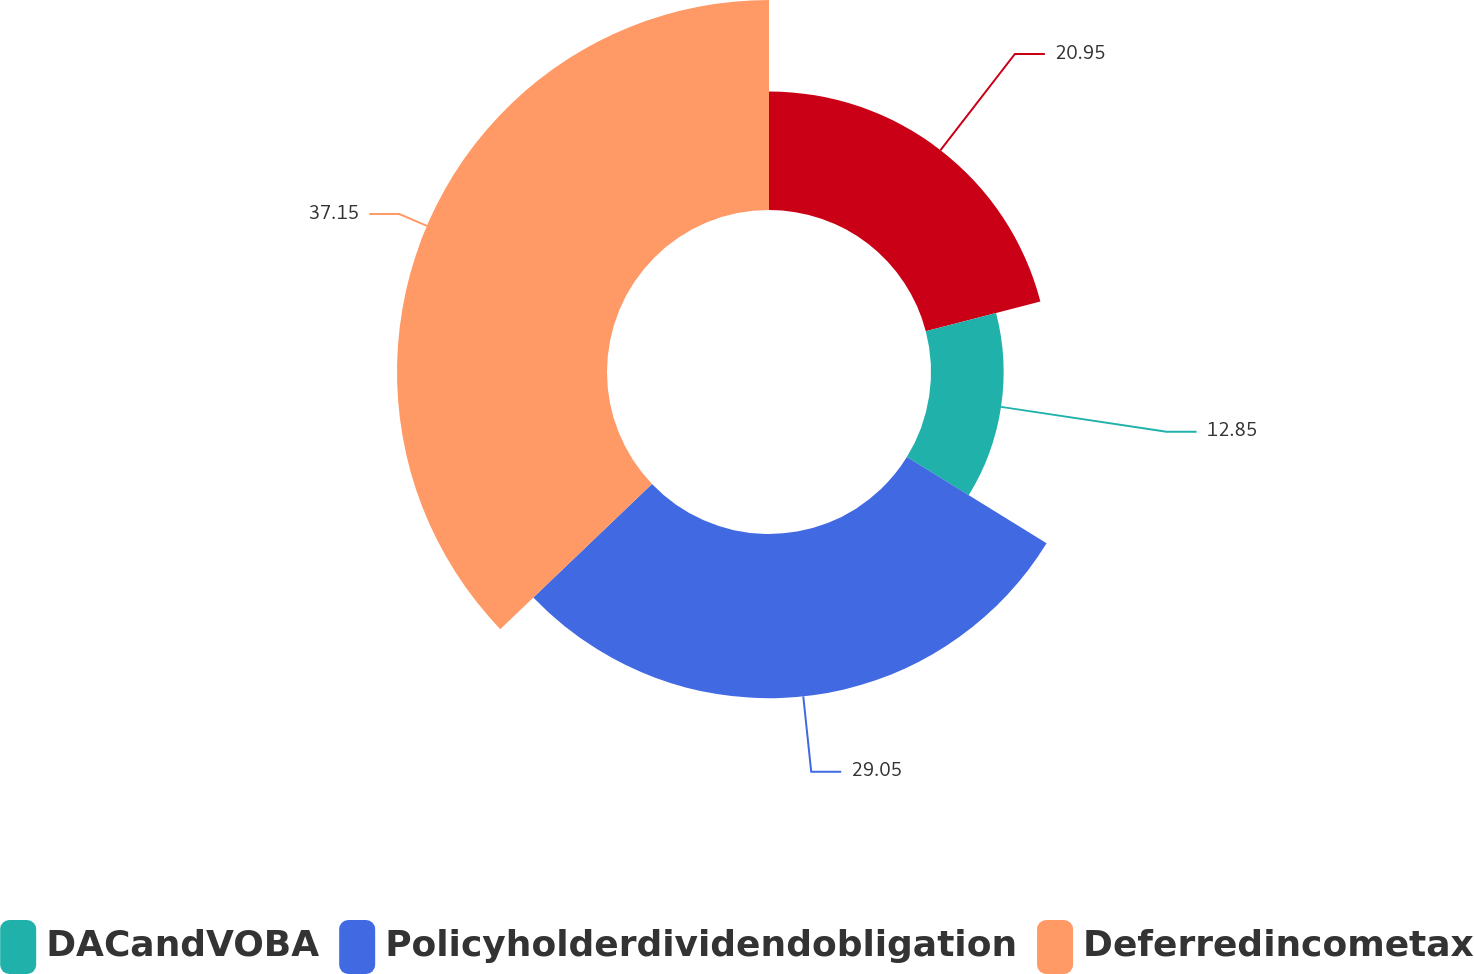Convert chart to OTSL. <chart><loc_0><loc_0><loc_500><loc_500><pie_chart><ecel><fcel>DACandVOBA<fcel>Policyholderdividendobligation<fcel>Deferredincometax<nl><fcel>20.95%<fcel>12.85%<fcel>29.05%<fcel>37.15%<nl></chart> 